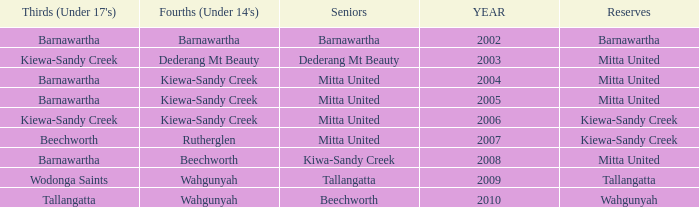Which Seniors have YEAR before 2006, and Fourths (Under 14's) of kiewa-sandy creek? Mitta United, Mitta United. 